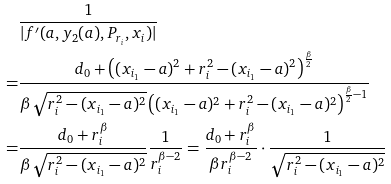<formula> <loc_0><loc_0><loc_500><loc_500>& \frac { 1 } { | f ^ { \prime } ( a , y _ { 2 } ( a ) , P _ { r _ { i } } , x _ { i } ) | } \\ = & \frac { d _ { 0 } + \left ( ( x _ { i _ { 1 } } - a ) ^ { 2 } + r _ { i } ^ { 2 } - ( x _ { i _ { 1 } } - a ) ^ { 2 } \right ) ^ { \frac { \beta } { 2 } } } { \beta \sqrt { r _ { i } ^ { 2 } - ( x _ { i _ { 1 } } - a ) ^ { 2 } } \left ( ( x _ { i _ { 1 } } - a ) ^ { 2 } + r _ { i } ^ { 2 } - ( x _ { i _ { 1 } } - a ) ^ { 2 } \right ) ^ { \frac { \beta } { 2 } - 1 } } \\ = & \frac { d _ { 0 } + r _ { i } ^ { \beta } } { \beta \sqrt { r _ { i } ^ { 2 } - ( x _ { i _ { 1 } } - a ) ^ { 2 } } } \frac { 1 } { r _ { i } ^ { \beta - 2 } } = \frac { d _ { 0 } + r _ { i } ^ { \beta } } { \beta r _ { i } ^ { \beta - 2 } } \cdot \frac { 1 } { \sqrt { r _ { i } ^ { 2 } - ( x _ { i _ { 1 } } - a ) ^ { 2 } } }</formula> 